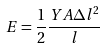<formula> <loc_0><loc_0><loc_500><loc_500>E = \frac { 1 } { 2 } \frac { Y A \Delta l ^ { 2 } } { l }</formula> 